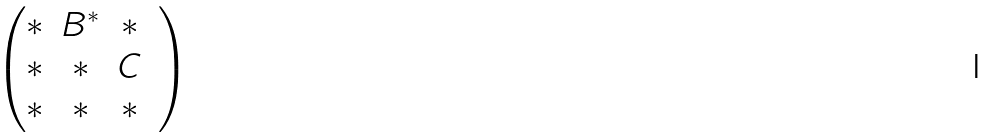<formula> <loc_0><loc_0><loc_500><loc_500>\begin{pmatrix} * & B ^ { * } & * & \\ * & * & C & \\ * & * & * & \\ \end{pmatrix}</formula> 